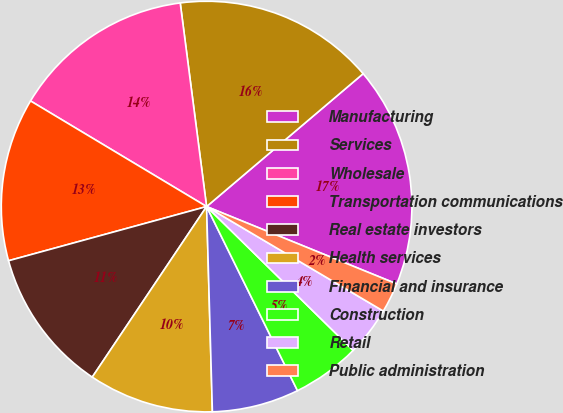Convert chart to OTSL. <chart><loc_0><loc_0><loc_500><loc_500><pie_chart><fcel>Manufacturing<fcel>Services<fcel>Wholesale<fcel>Transportation communications<fcel>Real estate investors<fcel>Health services<fcel>Financial and insurance<fcel>Construction<fcel>Retail<fcel>Public administration<nl><fcel>17.35%<fcel>15.85%<fcel>14.35%<fcel>12.85%<fcel>11.35%<fcel>9.85%<fcel>6.85%<fcel>5.35%<fcel>3.85%<fcel>2.35%<nl></chart> 